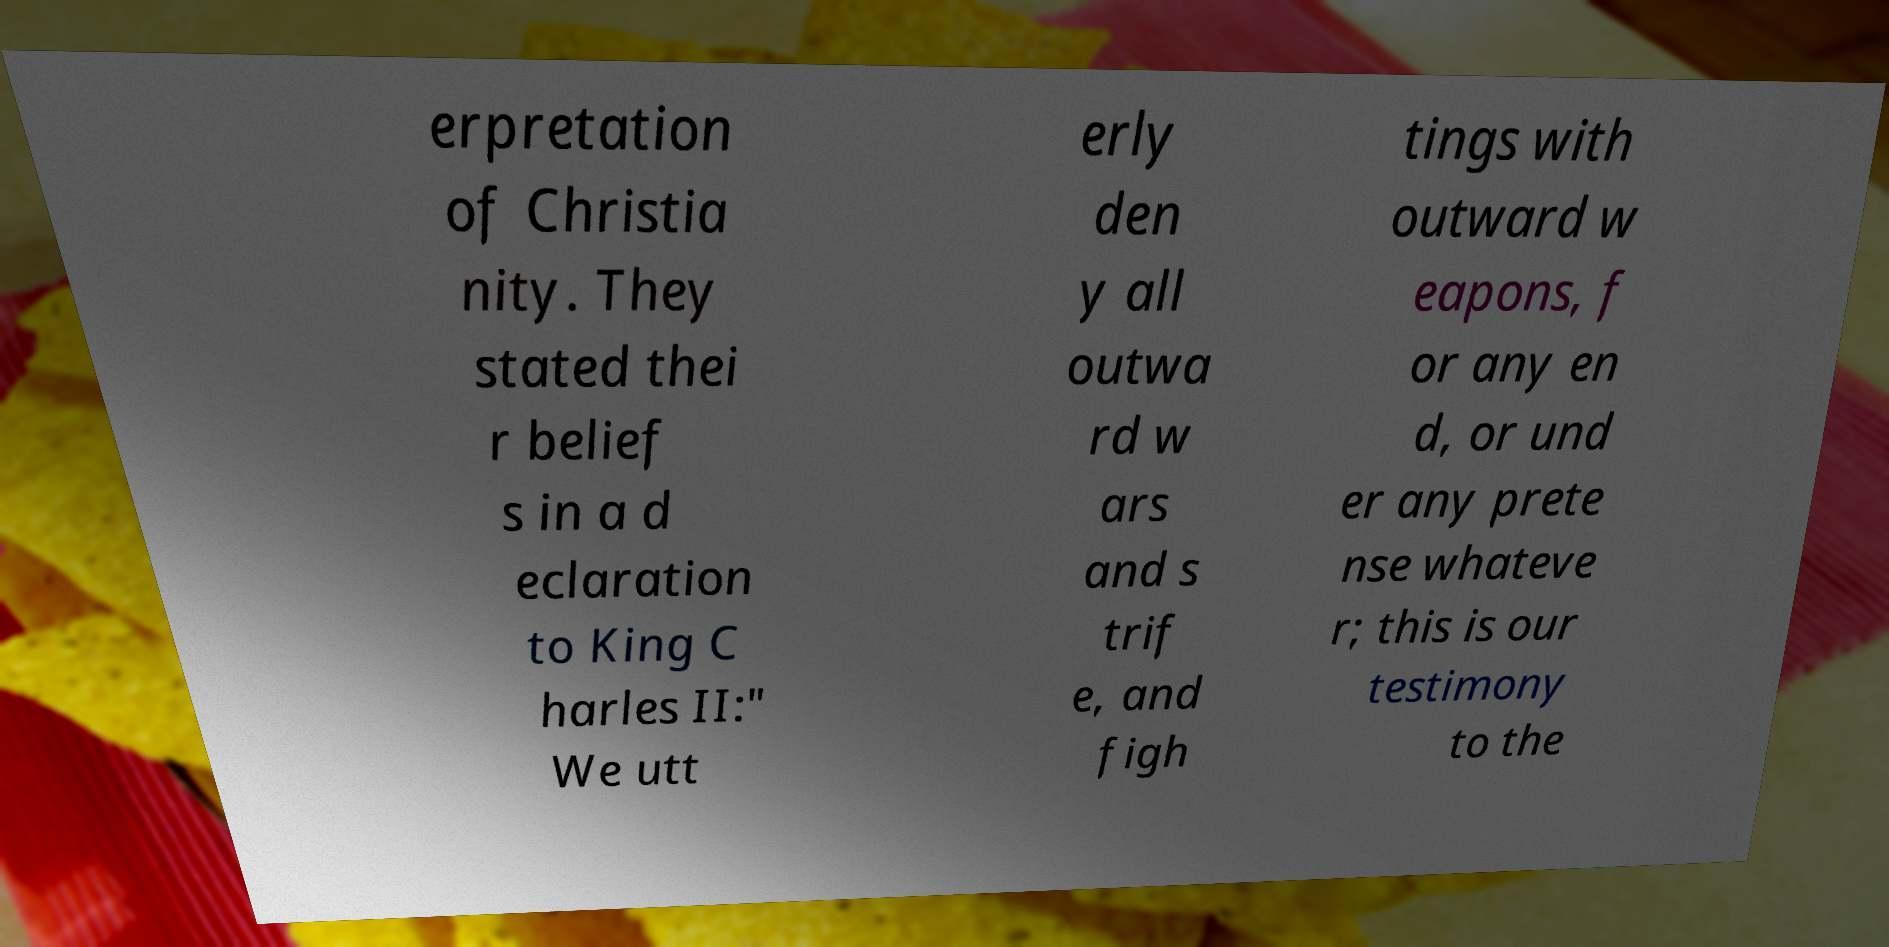Please identify and transcribe the text found in this image. erpretation of Christia nity. They stated thei r belief s in a d eclaration to King C harles II:" We utt erly den y all outwa rd w ars and s trif e, and figh tings with outward w eapons, f or any en d, or und er any prete nse whateve r; this is our testimony to the 